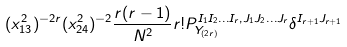Convert formula to latex. <formula><loc_0><loc_0><loc_500><loc_500>( x _ { 1 3 } ^ { 2 } ) ^ { - 2 r } ( x _ { 2 4 } ^ { 2 } ) ^ { - 2 } \frac { r ( r - 1 ) } { N ^ { 2 } } r ! P _ { Y _ { ( 2 r ) } } ^ { I _ { 1 } I _ { 2 } \dots I _ { r } , J _ { 1 } J _ { 2 } \dots J _ { r } } \delta ^ { I _ { r + 1 } J _ { r + 1 } }</formula> 